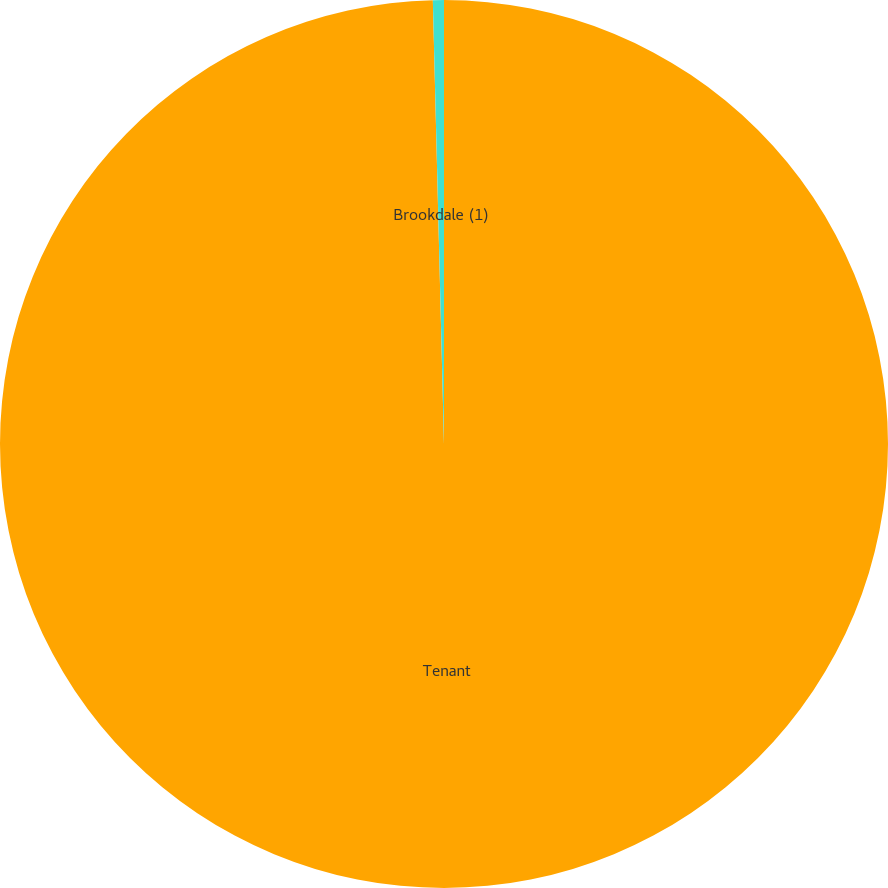Convert chart to OTSL. <chart><loc_0><loc_0><loc_500><loc_500><pie_chart><fcel>Tenant<fcel>Brookdale (1)<nl><fcel>99.6%<fcel>0.4%<nl></chart> 